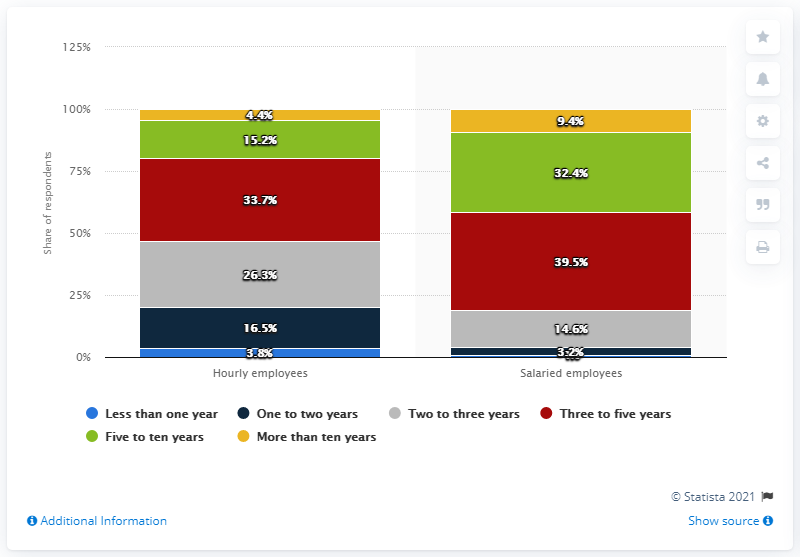Give some essential details in this illustration. According to the survey, 26.3% of respondents reported that their hourly employees at their establishment typically stayed for two to three years on average. 